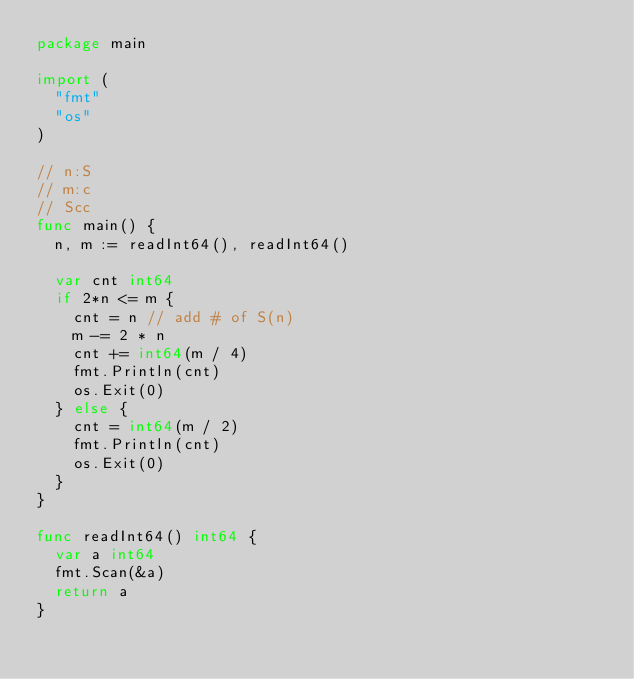Convert code to text. <code><loc_0><loc_0><loc_500><loc_500><_Go_>package main

import (
	"fmt"
	"os"
)

// n:S
// m:c
// Scc
func main() {
	n, m := readInt64(), readInt64()

	var cnt int64
	if 2*n <= m {
		cnt = n // add # of S(n)
		m -= 2 * n
		cnt += int64(m / 4)
		fmt.Println(cnt)
		os.Exit(0)
	} else {
		cnt = int64(m / 2)
		fmt.Println(cnt)
		os.Exit(0)
	}
}

func readInt64() int64 {
	var a int64
	fmt.Scan(&a)
	return a
}
</code> 